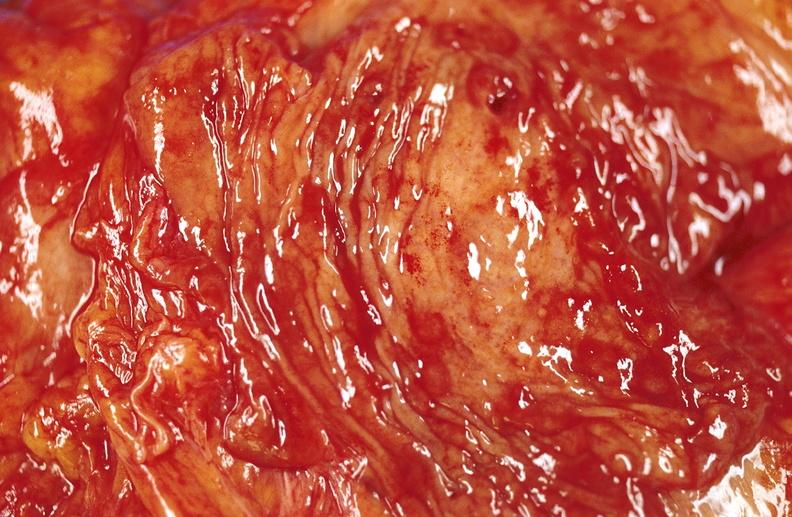does pituitary show duodenal ulcer?
Answer the question using a single word or phrase. No 